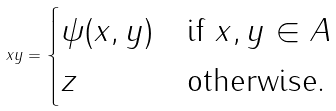<formula> <loc_0><loc_0><loc_500><loc_500>x y = \begin{cases} \psi ( x , y ) & \text {if } x , y \in A \\ z & \text {otherwise.} \end{cases}</formula> 